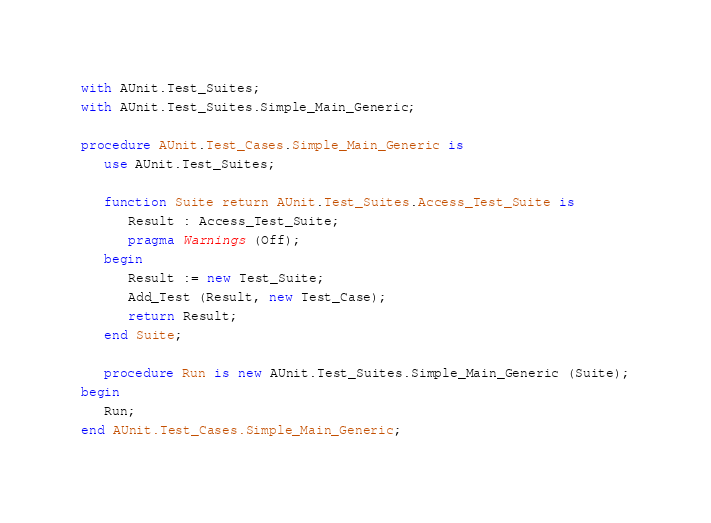Convert code to text. <code><loc_0><loc_0><loc_500><loc_500><_Ada_>
with AUnit.Test_Suites;
with AUnit.Test_Suites.Simple_Main_Generic;

procedure AUnit.Test_Cases.Simple_Main_Generic is
   use AUnit.Test_Suites;

   function Suite return AUnit.Test_Suites.Access_Test_Suite is
      Result : Access_Test_Suite;
      pragma Warnings (Off);
   begin
      Result := new Test_Suite;
      Add_Test (Result, new Test_Case);
      return Result;
   end Suite;

   procedure Run is new AUnit.Test_Suites.Simple_Main_Generic (Suite);
begin
   Run;
end AUnit.Test_Cases.Simple_Main_Generic;
</code> 